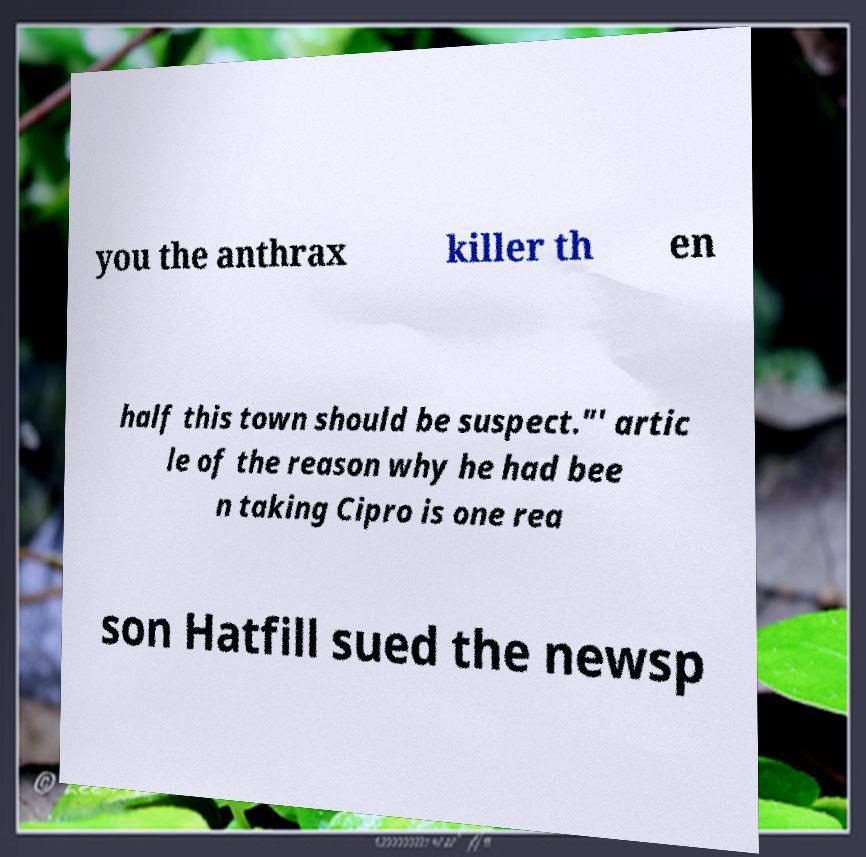For documentation purposes, I need the text within this image transcribed. Could you provide that? you the anthrax killer th en half this town should be suspect."' artic le of the reason why he had bee n taking Cipro is one rea son Hatfill sued the newsp 